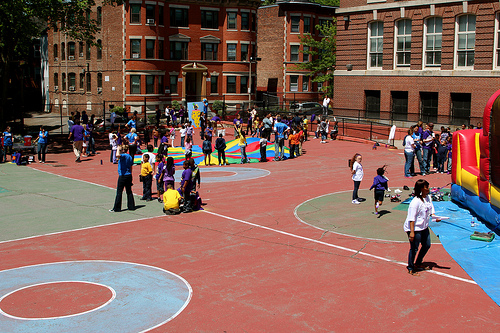<image>
Can you confirm if the building is behind the woman? Yes. From this viewpoint, the building is positioned behind the woman, with the woman partially or fully occluding the building. Is there a child to the right of the circle? No. The child is not to the right of the circle. The horizontal positioning shows a different relationship. 